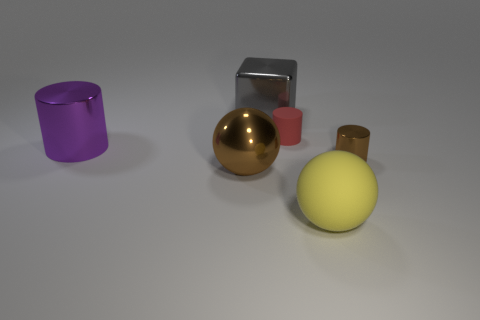Subtract all tiny brown cylinders. How many cylinders are left? 2 Subtract all cubes. How many objects are left? 5 Add 1 objects. How many objects exist? 7 Subtract all purple cylinders. How many cylinders are left? 2 Subtract 1 balls. How many balls are left? 1 Subtract all cyan blocks. Subtract all green cylinders. How many blocks are left? 1 Subtract all purple balls. How many blue blocks are left? 0 Subtract all metallic cubes. Subtract all big rubber objects. How many objects are left? 4 Add 3 large yellow balls. How many large yellow balls are left? 4 Add 6 shiny things. How many shiny things exist? 10 